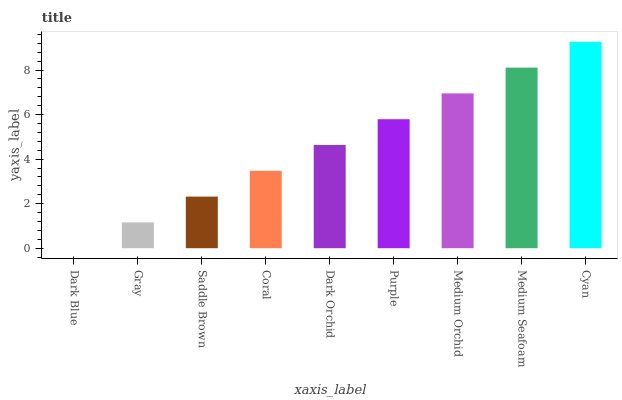Is Dark Blue the minimum?
Answer yes or no. Yes. Is Cyan the maximum?
Answer yes or no. Yes. Is Gray the minimum?
Answer yes or no. No. Is Gray the maximum?
Answer yes or no. No. Is Gray greater than Dark Blue?
Answer yes or no. Yes. Is Dark Blue less than Gray?
Answer yes or no. Yes. Is Dark Blue greater than Gray?
Answer yes or no. No. Is Gray less than Dark Blue?
Answer yes or no. No. Is Dark Orchid the high median?
Answer yes or no. Yes. Is Dark Orchid the low median?
Answer yes or no. Yes. Is Medium Orchid the high median?
Answer yes or no. No. Is Medium Orchid the low median?
Answer yes or no. No. 